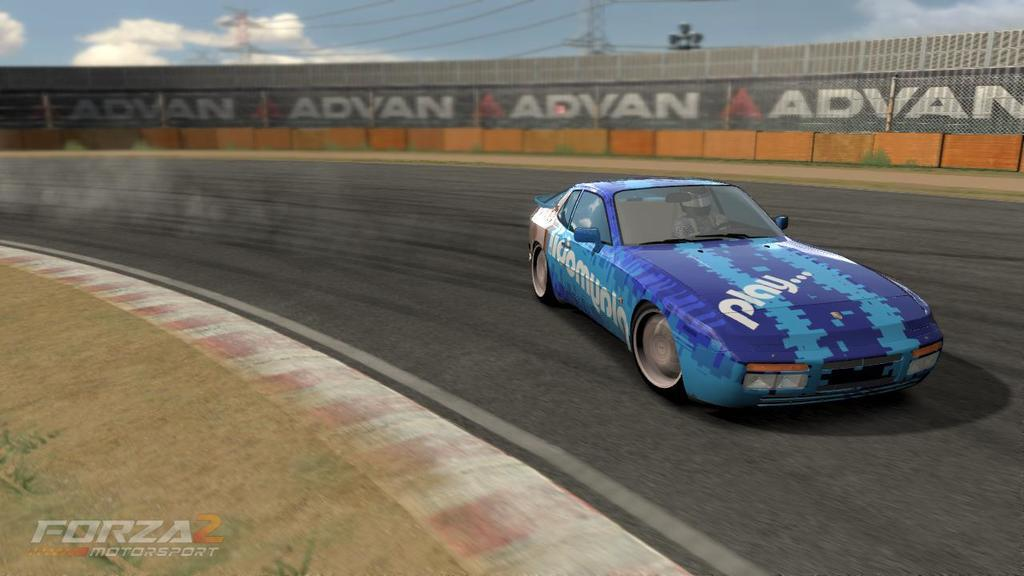What is happening in the image? There is a car moving on the road in the image. What can be seen in the background of the image? There is a wall with some text in the background of the image. Is there any text present within the image? Yes, there is some text at the bottom of the image. What type of plate is being used by the giants in the image? There are no giants or plates present in the image. 